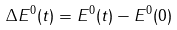Convert formula to latex. <formula><loc_0><loc_0><loc_500><loc_500>\Delta { E ^ { 0 } ( t ) } = E ^ { 0 } ( t ) - E ^ { 0 } ( 0 )</formula> 